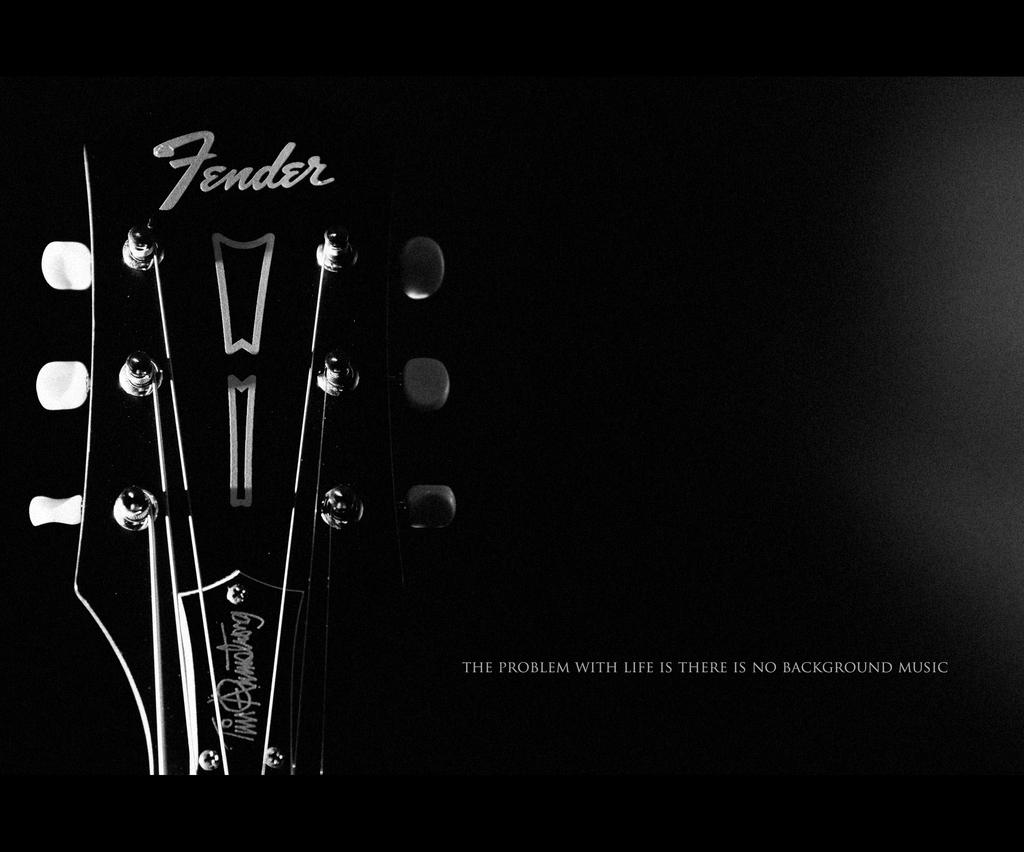What is the main object in the picture? There is a guitar in the picture. Where can text be found in the image? Text can be found at the bottom right side of the picture and on the guitar. What is the color of the background in the image? The background of the image is dark. How many prisoners are visible in the image? There are no prisoners present in the image; it features a guitar and text. What type of straw is used to play the guitar in the image? There is no straw present in the image, and guitars are typically played with fingers or a pick, not a straw. 